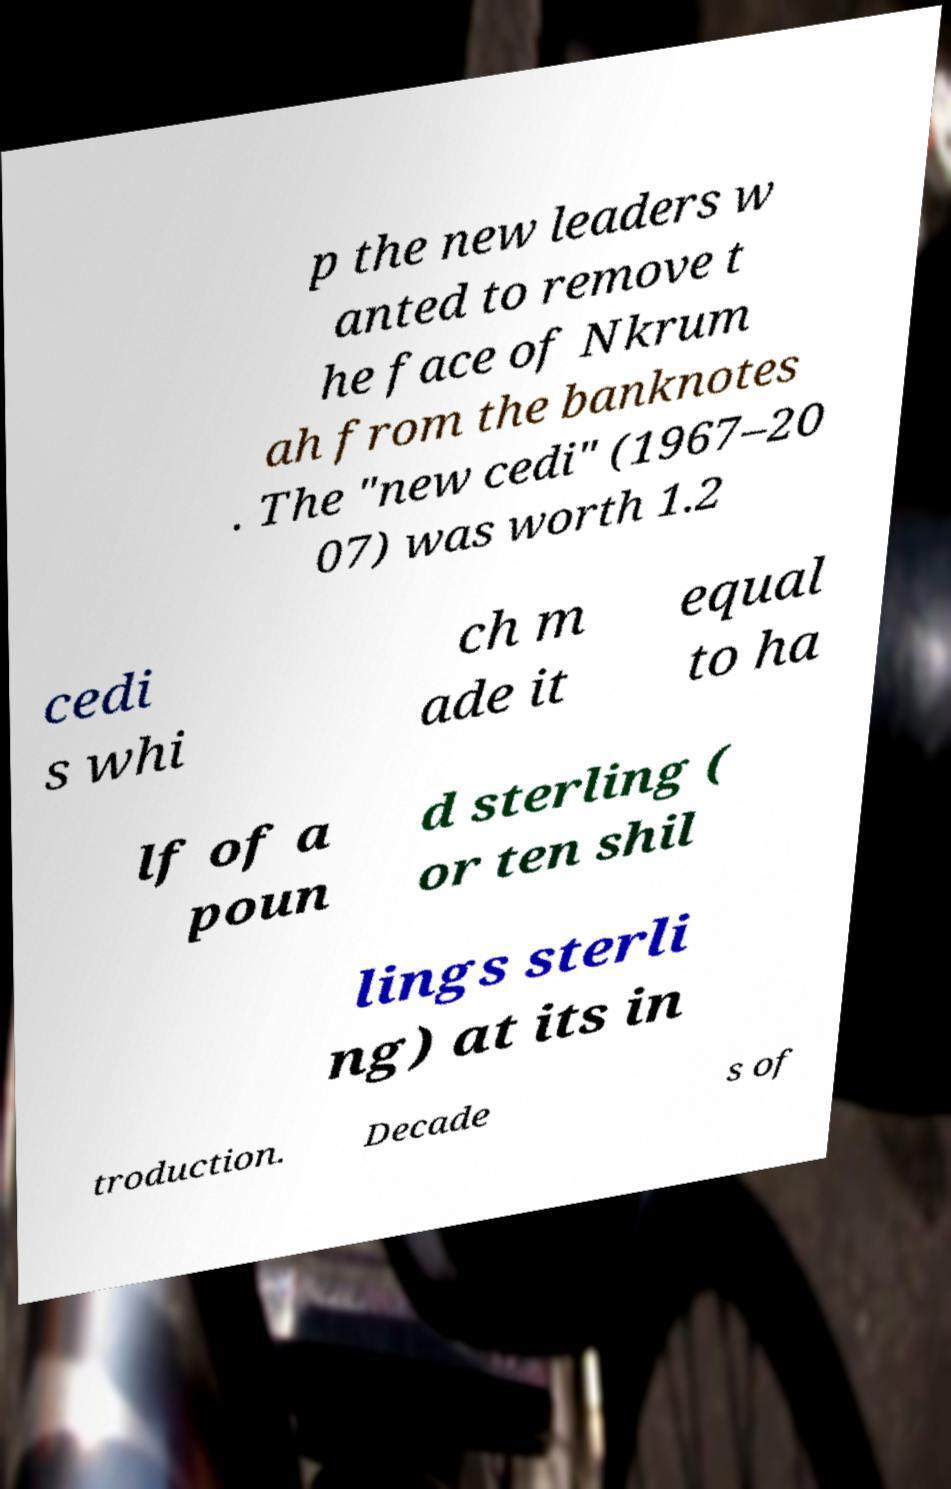For documentation purposes, I need the text within this image transcribed. Could you provide that? p the new leaders w anted to remove t he face of Nkrum ah from the banknotes . The "new cedi" (1967–20 07) was worth 1.2 cedi s whi ch m ade it equal to ha lf of a poun d sterling ( or ten shil lings sterli ng) at its in troduction. Decade s of 